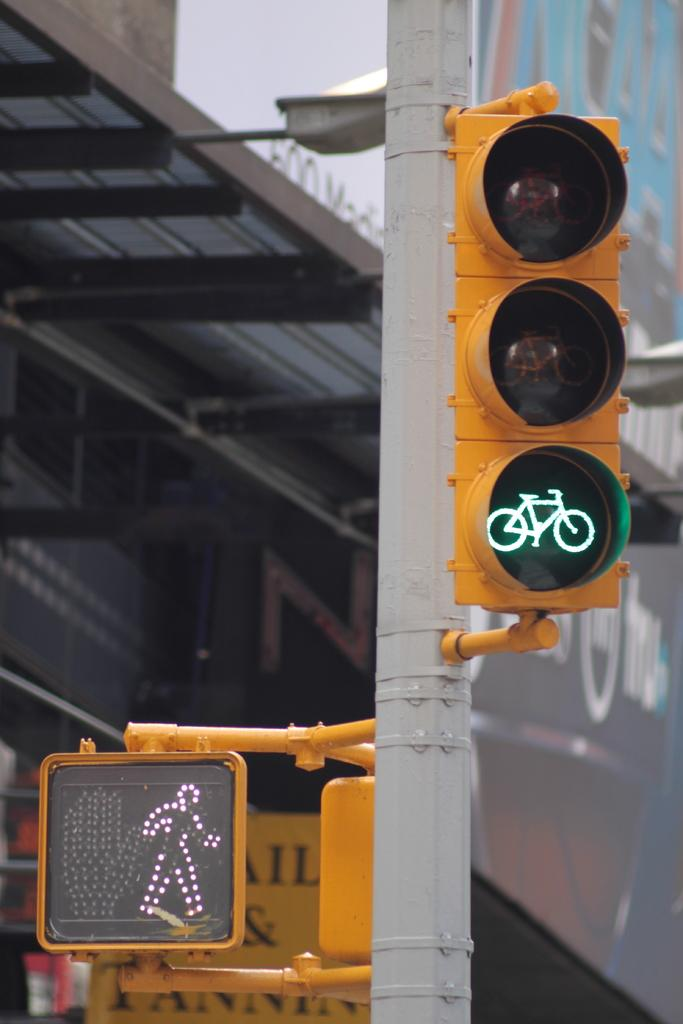<image>
Provide a brief description of the given image. a walk and a bike sign with a tanner sign in the background 